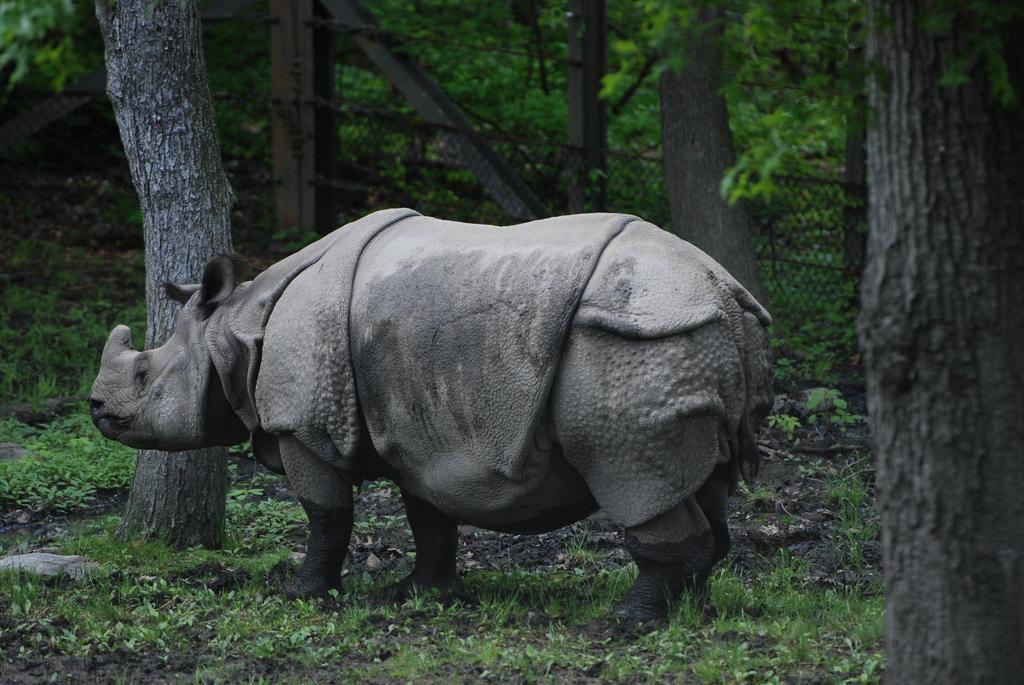Please provide a concise description of this image. In this picture I can see a rhinoceros and I can see trees in the back and few plants. 